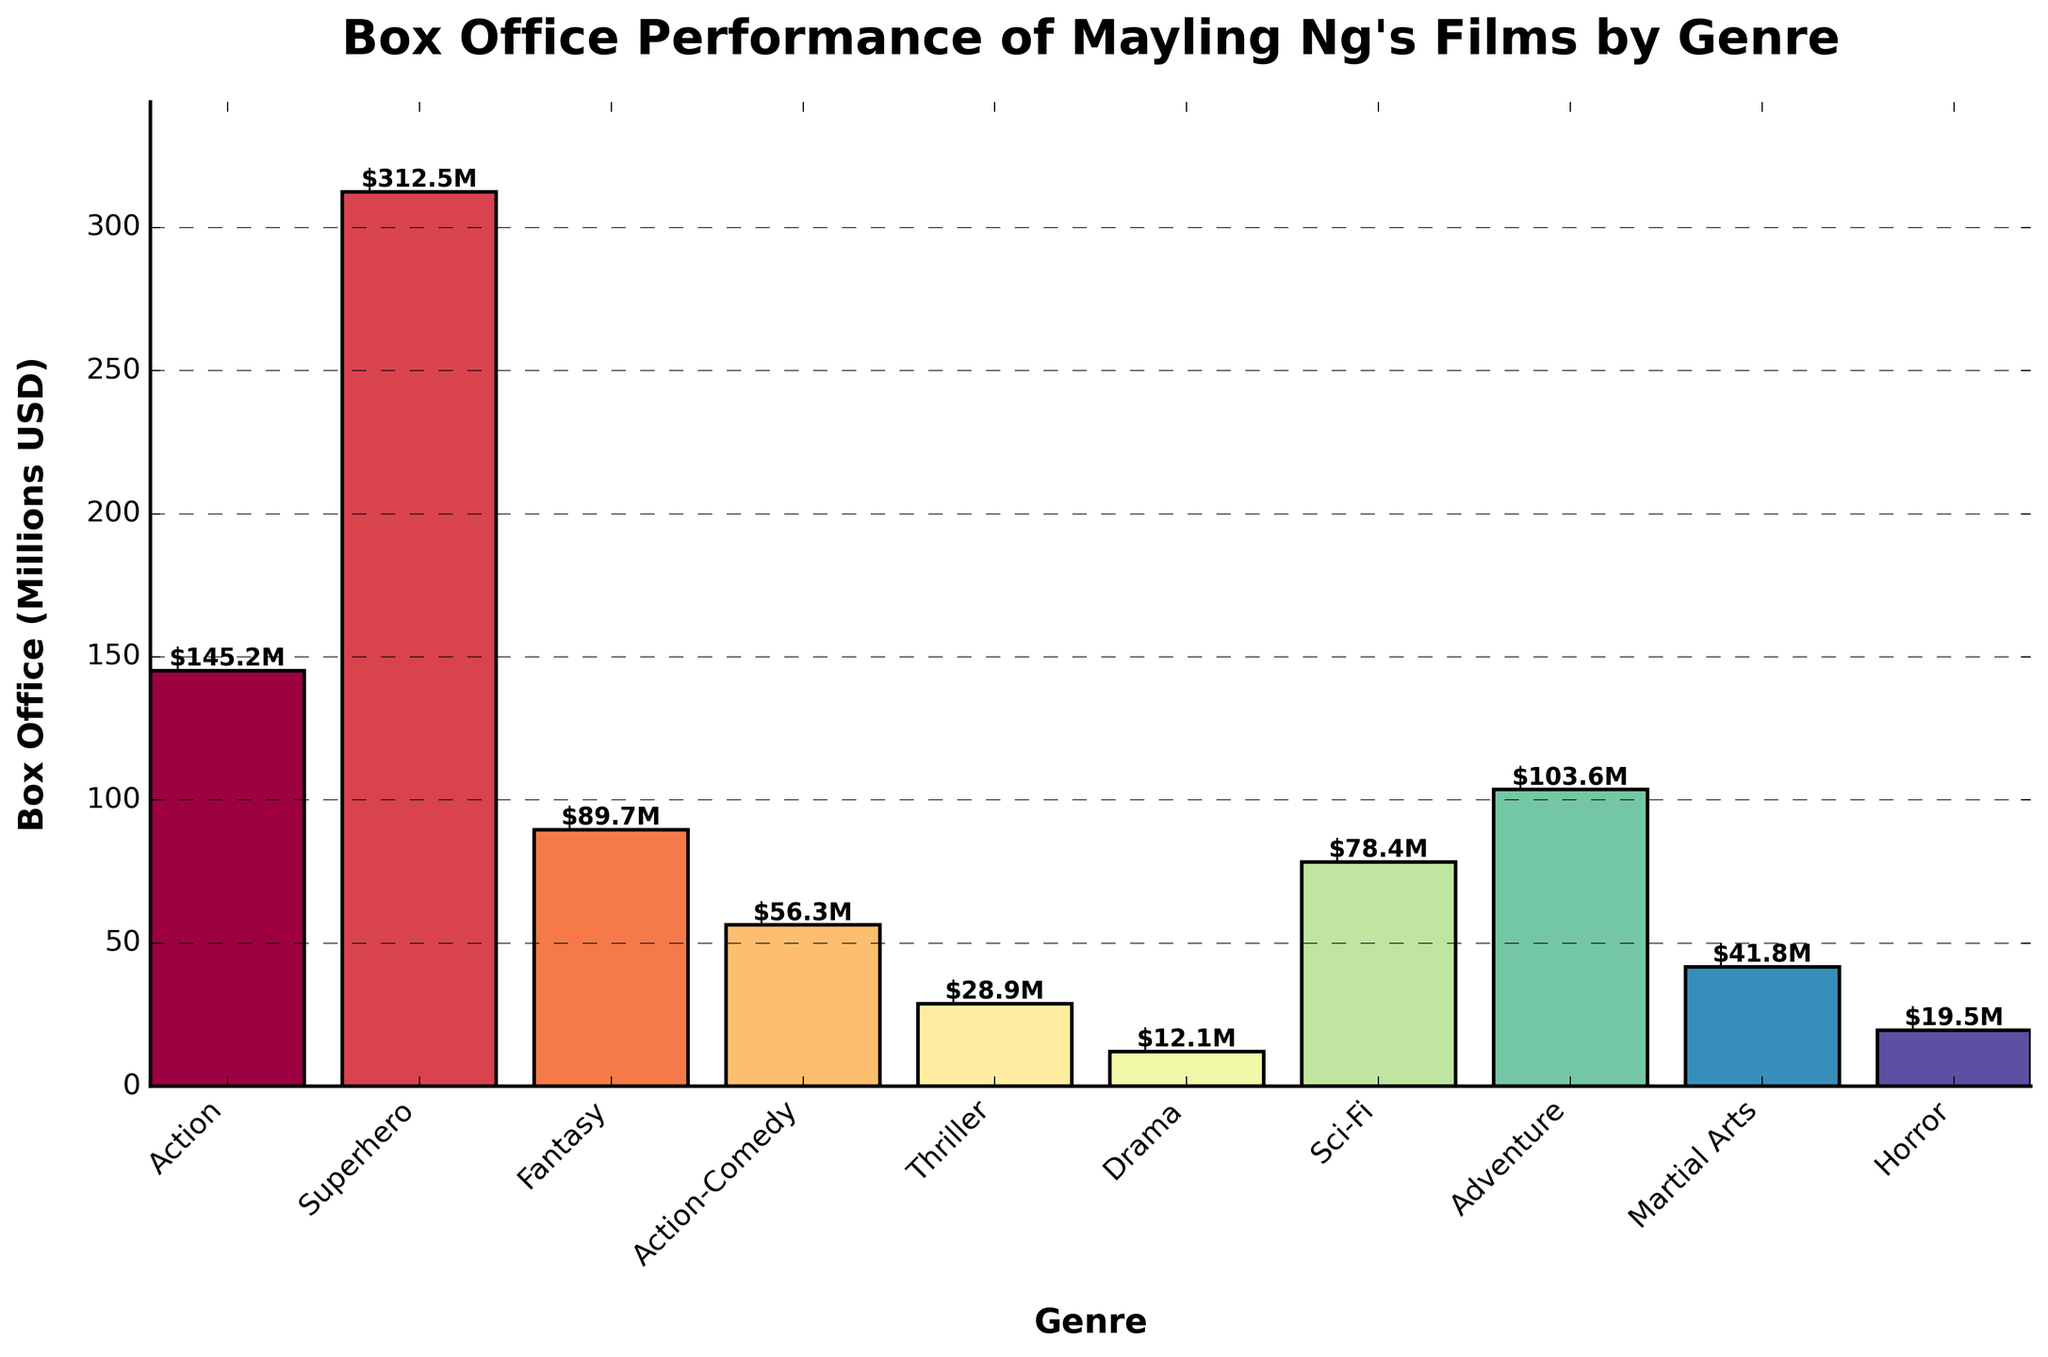What genre has the highest box office performance? The tallest bar in the chart represents the genre with the highest box office performance. The Superhero genre bar is the highest, reaching $312.5 million.
Answer: Superhero Which genre has the lowest box office performance? The shortest bar in the chart represents the genre with the lowest box office performance. The Drama genre bar is the shortest, with $12.1 million.
Answer: Drama What is the total box office performance of Action and Adventure genres combined? Find the heights of the bars for the Action and Adventure genres and sum them up: $145.2 million (Action) + $103.6 million (Adventure) = $248.8 million.
Answer: $248.8 million Which genre has a higher box office performance: Action-Comedy or Sci-Fi? Compare the heights of the bars for Action-Comedy and Sci-Fi. The Sci-Fi bar is higher, representing $78.4 million compared to Action-Comedy's $56.3 million.
Answer: Sci-Fi What is the average box office performance across all genres? Sum the box office performances of all genres and divide by the number of genres: (145.2 + 312.5 + 89.7 + 56.3 + 28.9 + 12.1 + 78.4 + 103.6 + 41.8 + 19.5) / 10 = 88.8 million.
Answer: $88.8 million How much more did the Action genre earn compared to Horror? Subtract the box office performance of Horror from Action: $145.2 million - $19.5 million = $125.7 million.
Answer: $125.7 million What is the ratio of box office earnings between Superhero and Thriller genres? Divide the box office performance of Superhero by Thriller: $312.5 million (Superhero) / $28.9 million (Thriller) ≈ 10.8.
Answer: ≈ 10.8 How much did the Fantasy genre earn more than the Martial Arts genre? Subtract the box office performance of Martial Arts from Fantasy: $89.7 million - $41.8 million = $47.9 million.
Answer: $47.9 million Which genres have a box office performance below $50 million? Identify the bars that are shorter than the $50 million mark. The genres are Action-Comedy ($56.3M), Thriller ($28.9M), Drama ($12.1M), Martial Arts ($41.8M), and Horror ($19.5M).
Answer: Thriller, Drama, Martial Arts, Horror 